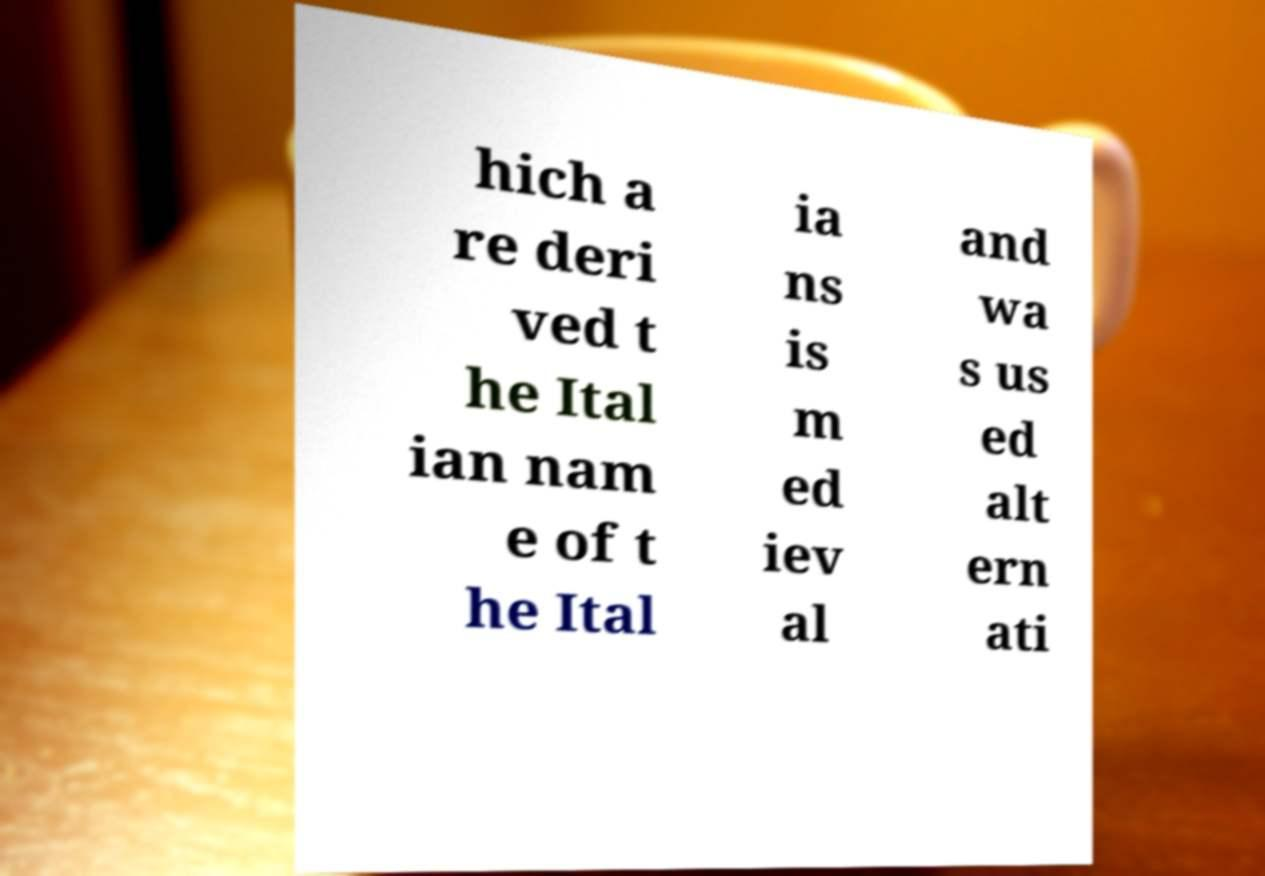Could you extract and type out the text from this image? hich a re deri ved t he Ital ian nam e of t he Ital ia ns is m ed iev al and wa s us ed alt ern ati 